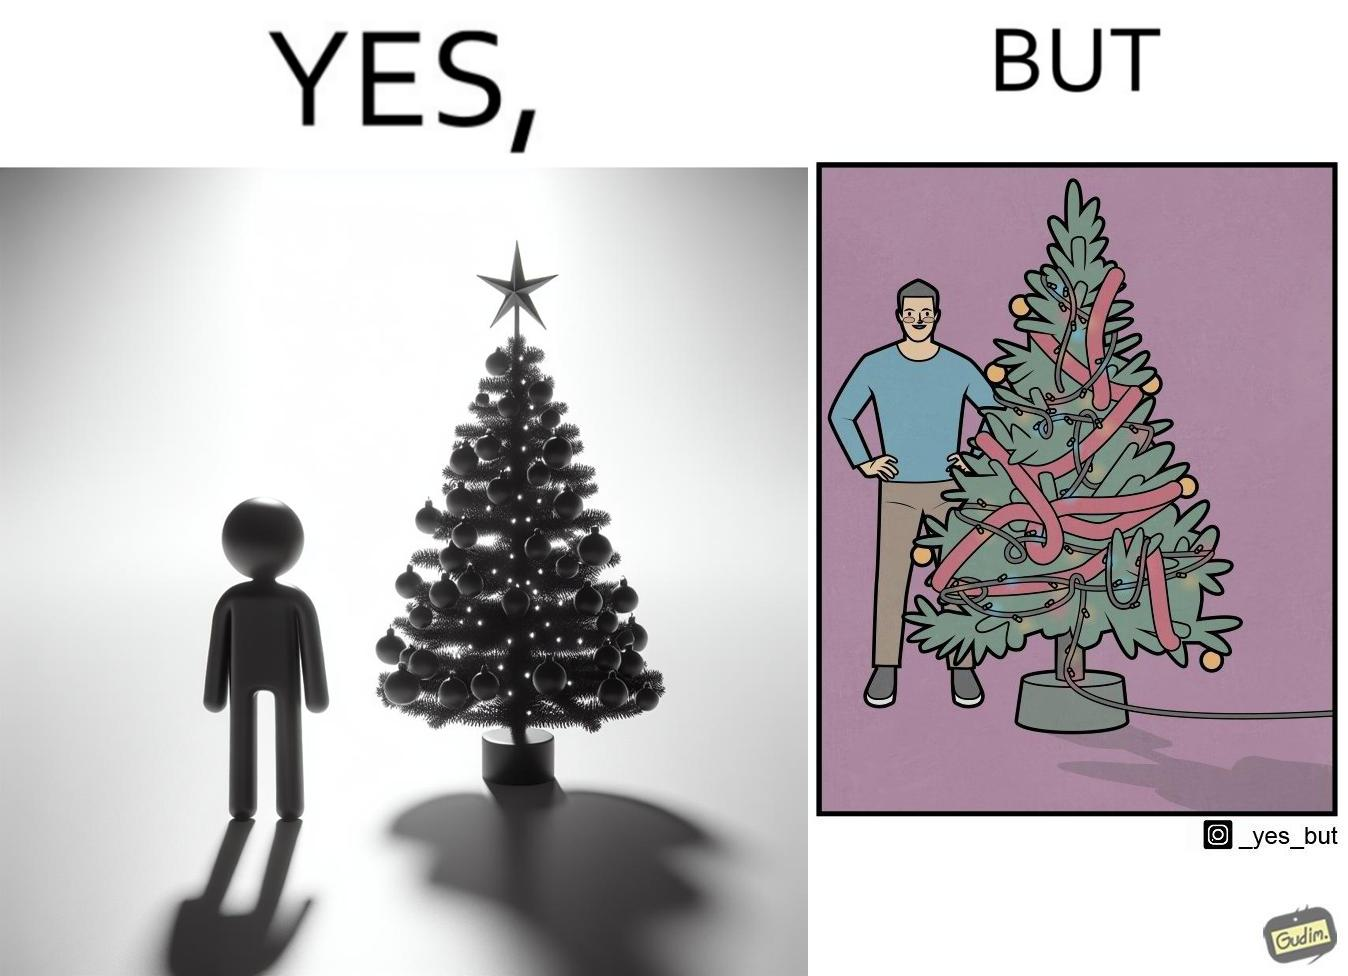Explain the humor or irony in this image. The image is ironic, because in the first image a person is seen watching his decorated X-mas tree but in the second image it is shown that the tree is looking beautiful not due to its natural beauty but the bulbs connected via power decorated over it 